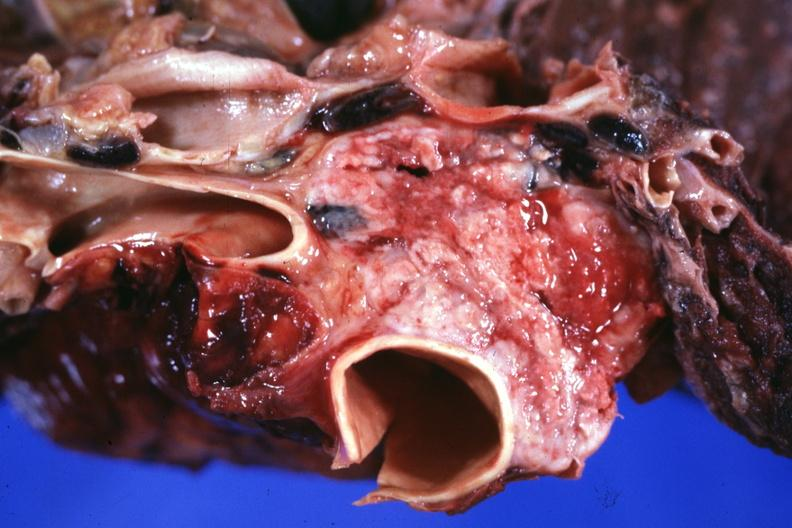s hematologic present?
Answer the question using a single word or phrase. Yes 